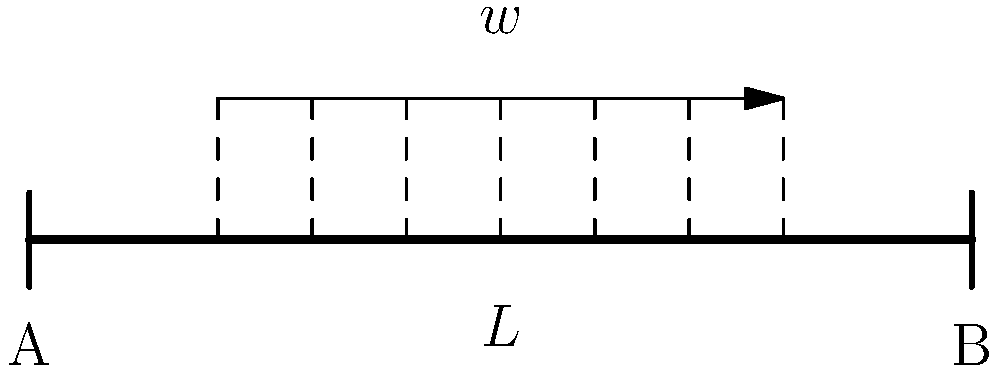A simply supported beam of length $L$ is subjected to a uniformly distributed load $w$ over the middle 60% of its span, as shown in the figure. Determine the maximum bending moment in the beam and its location. How does this compare to the maximum bending moment if the load was distributed over the entire span? To solve this problem, we'll follow these steps:

1) First, let's calculate the reactions at the supports:
   Due to symmetry, $R_A = R_B = 0.6wL/2 = 0.3wL$

2) The maximum bending moment will occur where the shear force is zero. Due to symmetry, this will be at the center of the beam.

3) To calculate the maximum bending moment:
   $M_{max} = R_A \cdot 0.5L - w \cdot 0.3L \cdot 0.15L$
   $M_{max} = 0.3wL \cdot 0.5L - 0.3wL \cdot 0.15L$
   $M_{max} = 0.15wL^2 - 0.045wL^2 = 0.105wL^2$

4) If the load was distributed over the entire span:
   $R_A = R_B = wL/2$
   $M_{max} = wL^2/8 = 0.125wL^2$

5) Comparing the two scenarios:
   $0.105wL^2 / 0.125wL^2 = 0.84$ or 84%

The maximum bending moment for the partially loaded beam is 84% of the fully loaded beam's maximum bending moment.

This result demonstrates how load distribution can significantly affect stress in a structure, a concept that could resonate with an activist concerned about efficient and sustainable design.
Answer: $M_{max} = 0.105wL^2$ at midspan; 84% of fully loaded beam 